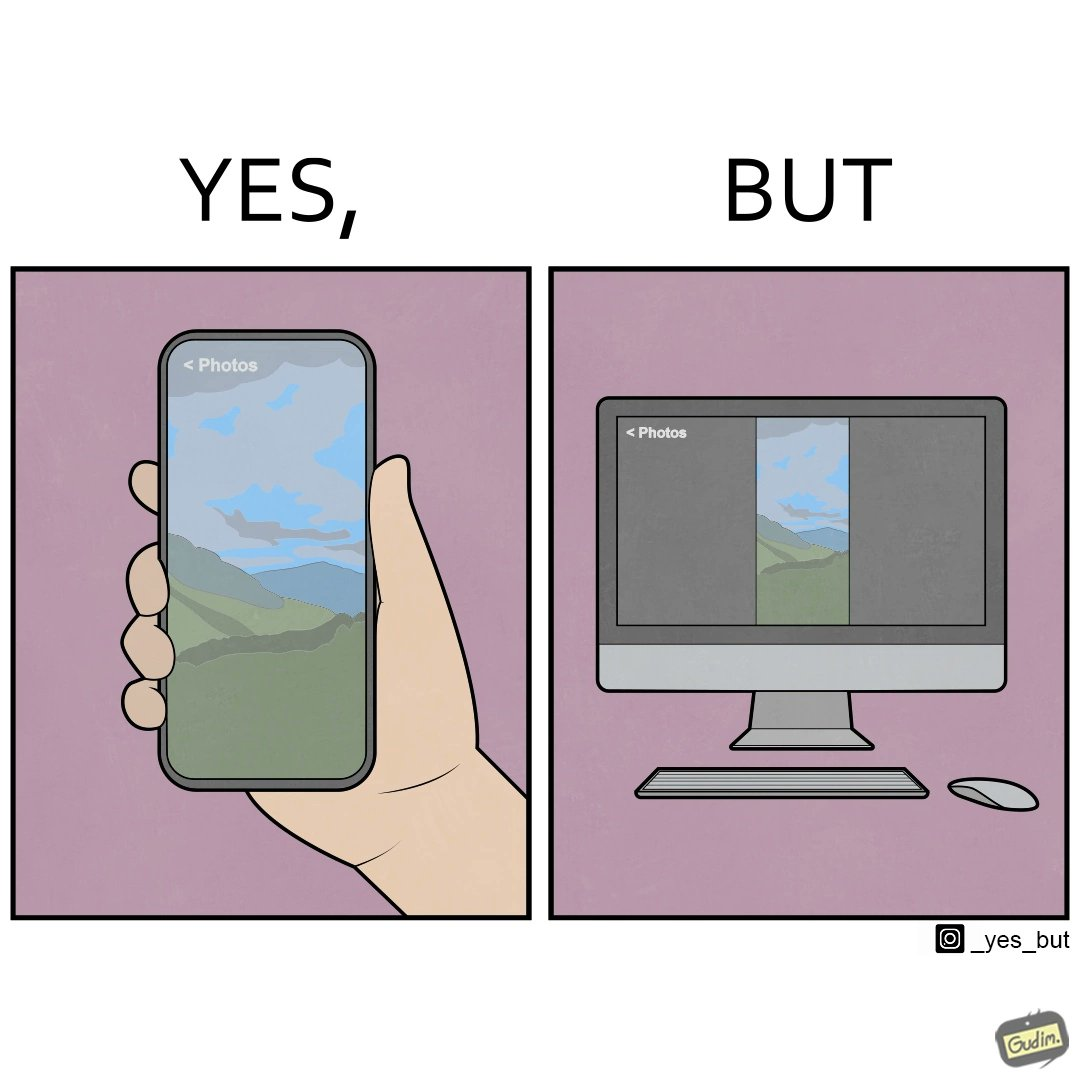Does this image contain satire or humor? Yes, this image is satirical. 